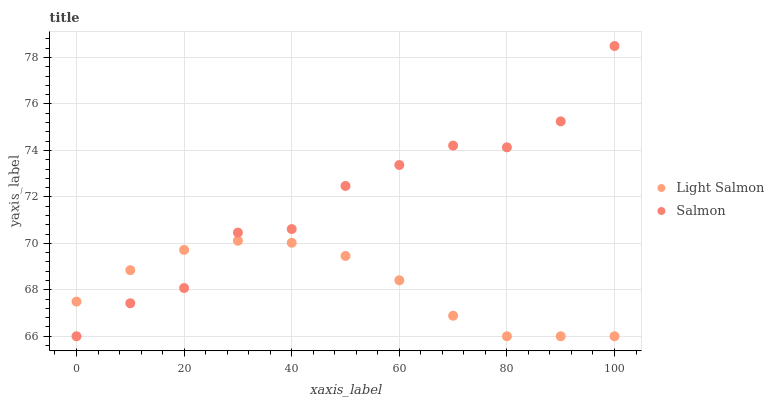Does Light Salmon have the minimum area under the curve?
Answer yes or no. Yes. Does Salmon have the maximum area under the curve?
Answer yes or no. Yes. Does Salmon have the minimum area under the curve?
Answer yes or no. No. Is Light Salmon the smoothest?
Answer yes or no. Yes. Is Salmon the roughest?
Answer yes or no. Yes. Is Salmon the smoothest?
Answer yes or no. No. Does Light Salmon have the lowest value?
Answer yes or no. Yes. Does Salmon have the highest value?
Answer yes or no. Yes. Does Salmon intersect Light Salmon?
Answer yes or no. Yes. Is Salmon less than Light Salmon?
Answer yes or no. No. Is Salmon greater than Light Salmon?
Answer yes or no. No. 